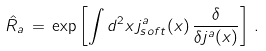<formula> <loc_0><loc_0><loc_500><loc_500>\hat { R } _ { a } \, = \, \exp \left [ \int d ^ { 2 } x \, j _ { s o f t } ^ { a } ( x ) \, \frac { \delta } { \delta j ^ { a } ( x ) } \right ] \, .</formula> 